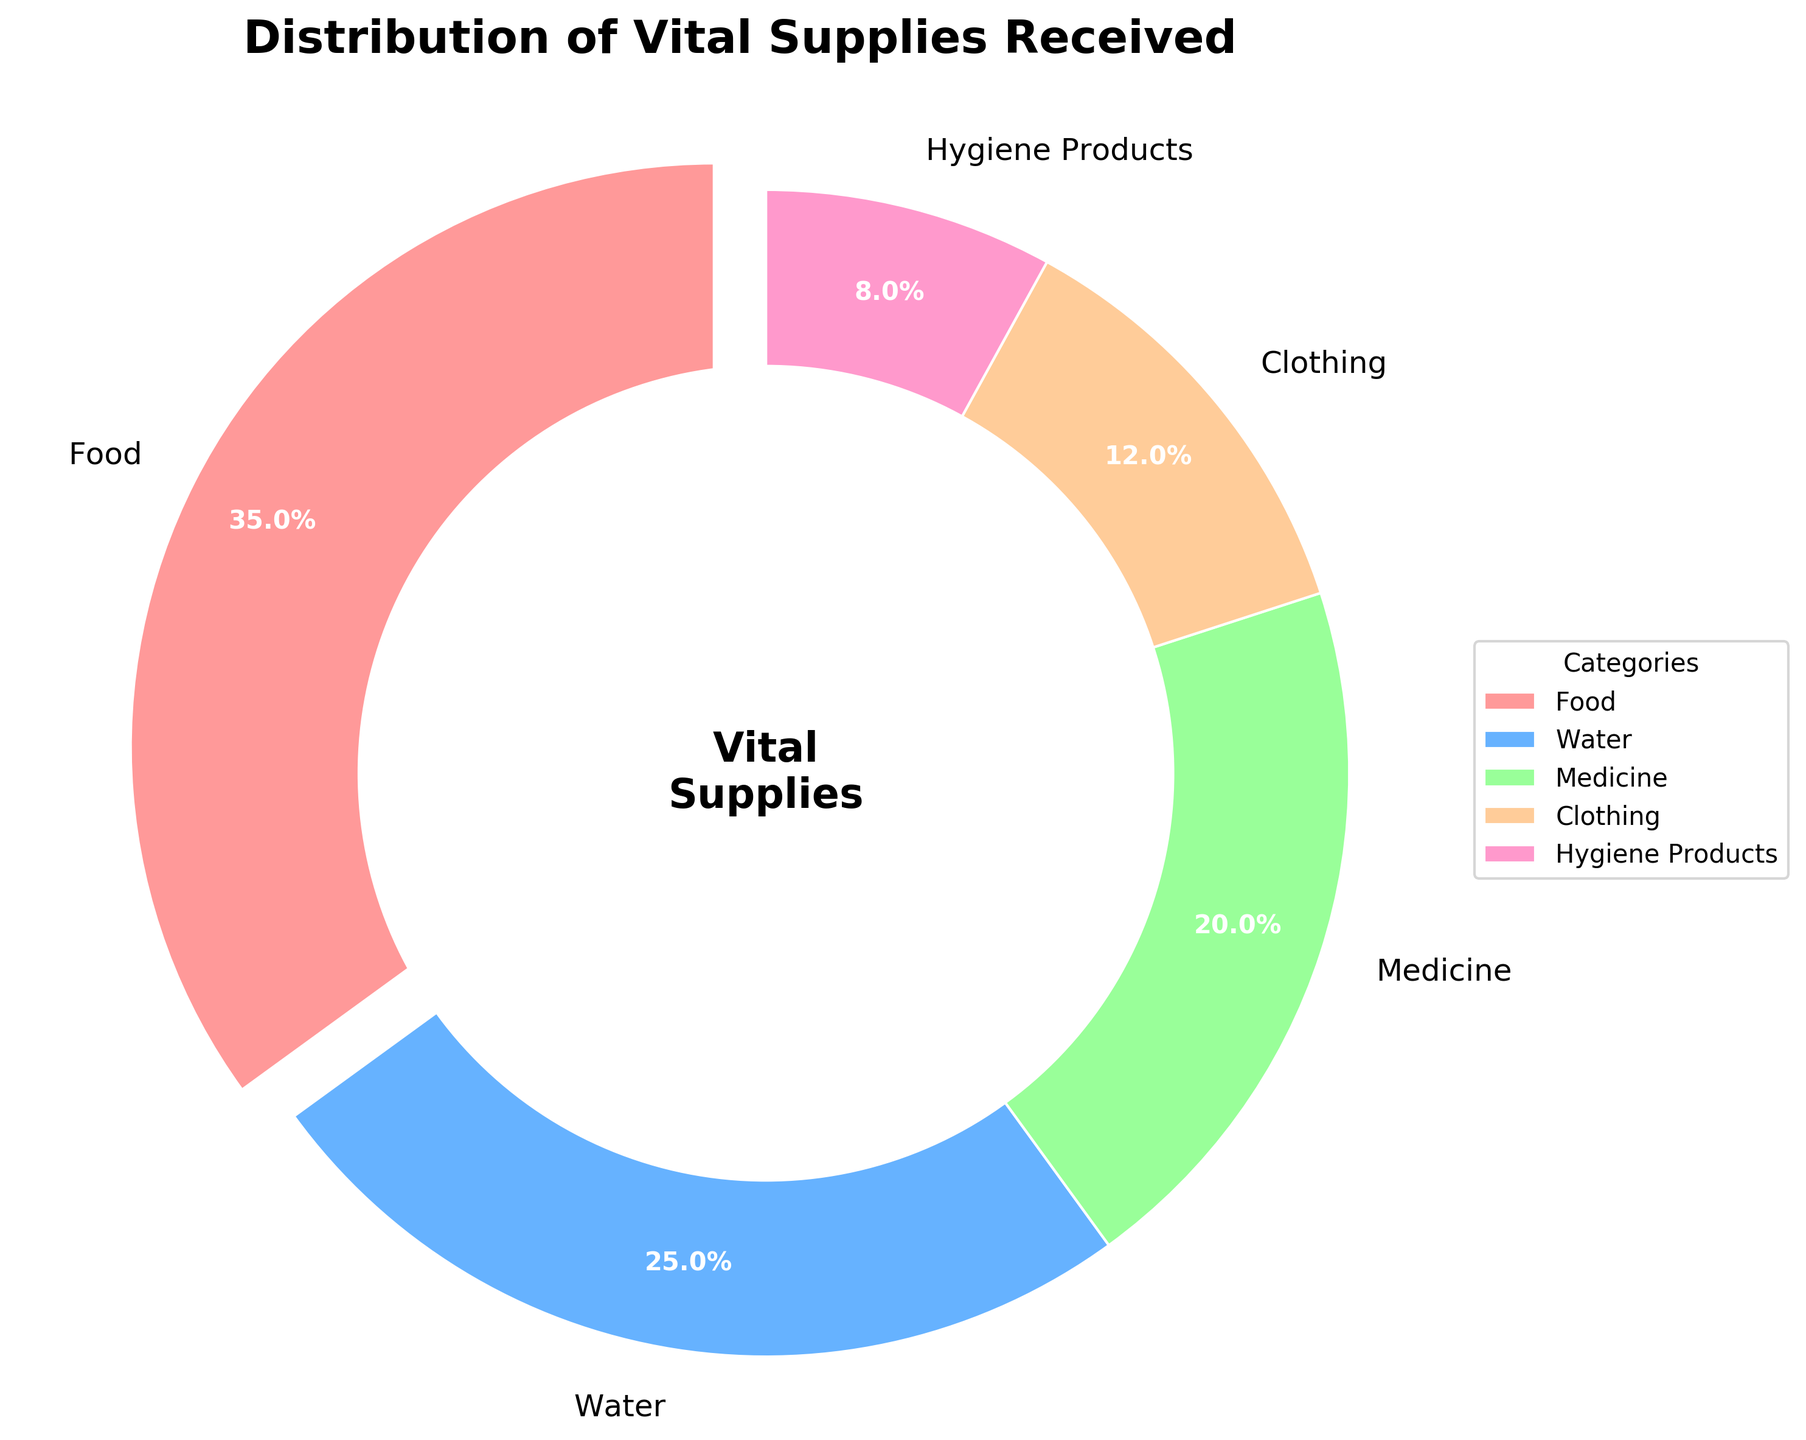What percentage of the supplies received is food? Food's percentage can be directly read from the figure, where it's labeled as 35%.
Answer: 35% Which category received the least amount of supplies? The figure shows all categories' percentages, where Hygiene Products is the smallest slice, labeled as 8%.
Answer: Hygiene Products How much more percentage of the supplies is food compared to clothing? Food and clothing percentages are shown as 35% and 12% respectively. Subtracting 12% from 35% gives the difference.
Answer: 23% Which two categories together received the same percentage of supplies as food? Percentages of categories are: Food (35%), Water (25%), Medicine (20%), Clothing (12%), and Hygiene Products (8%). Adding Water and Medicine gives 25% + 20%.
Answer: Water and Medicine How many categories received a higher percentage of supplies than hygiene products? Hygiene Products received 8%. Categories receiving more are: Food (35%), Water (25%), Medicine (20%), and Clothing (12%), resulting in four categories.
Answer: 4 What is the total percentage of supplies received by water and hygiene products combined? Water and Hygiene Products' percentages are 25% and 8%. Adding these together gives 33%.
Answer: 33% Which category received approximately three times the percentage of hygiene products? Hygiene Products received 8%. Food received 35%, which is approximately 3 times 8% (8 x 3 = 24) but is closer in whole number comparison.
Answer: Food Compare the percentage of supplies received by medicine and water. Which one is higher, and by how much? Water received 25%, Medicine 20%. Subtracting 20% from 25% shows Water received 5% more.
Answer: Water, by 5% What two categories together account for over half of the total supplies? Looking at the largest slices, Food (35%) and Water (25%) together exceed 50%, totaling 60%.
Answer: Food and Water What proportion of the total supplies goes to non-food categories? Subtracting Food's proportion (35%) from 100% gives the non-food categories' total percentage.
Answer: 65% 